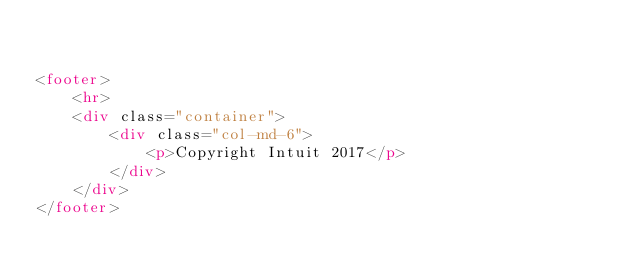<code> <loc_0><loc_0><loc_500><loc_500><_HTML_>

<footer>
    <hr>
    <div class="container">
        <div class="col-md-6">
            <p>Copyright Intuit 2017</p>
        </div>
    </div>
</footer>
</code> 